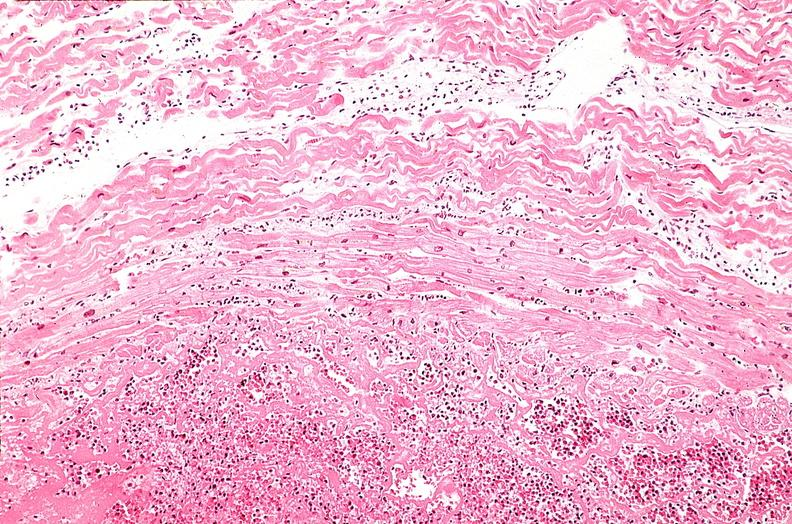what is present?
Answer the question using a single word or phrase. Cardiovascular 